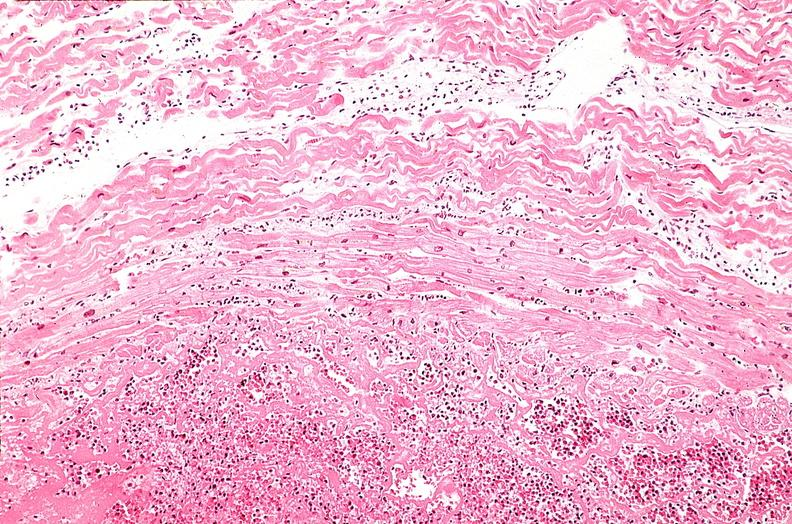what is present?
Answer the question using a single word or phrase. Cardiovascular 